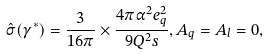<formula> <loc_0><loc_0><loc_500><loc_500>\hat { \sigma } ( \gamma ^ { * } ) = \frac { 3 } { 1 6 \pi } \times \frac { 4 \pi \alpha ^ { 2 } e _ { q } ^ { 2 } } { 9 Q ^ { 2 } s } , A _ { q } = A _ { l } = 0 ,</formula> 